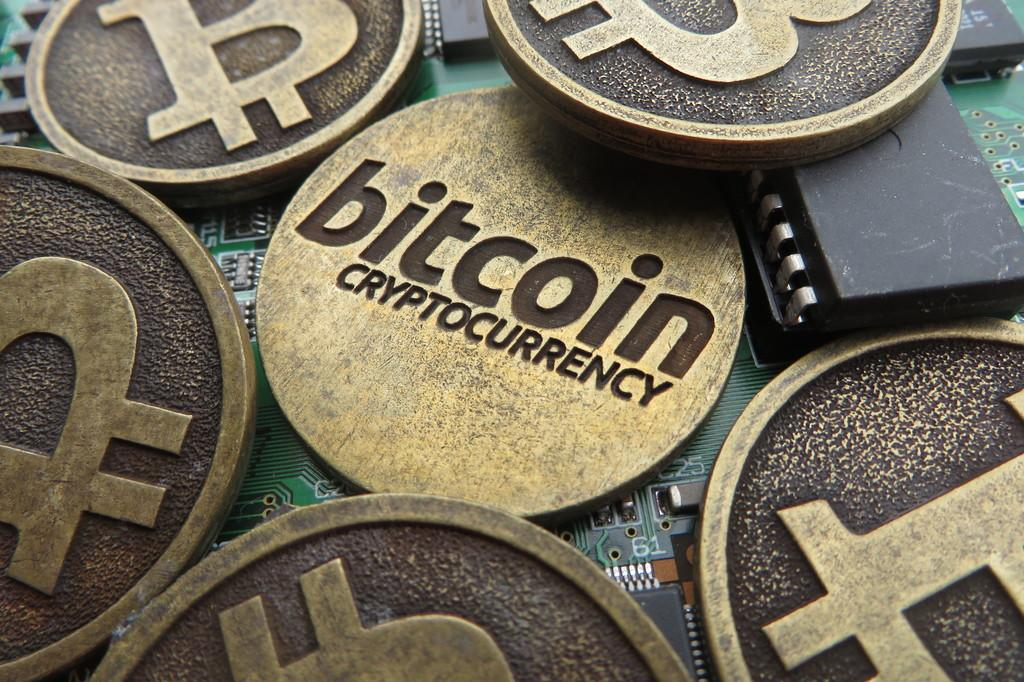<image>
Share a concise interpretation of the image provided. A few gold and black coins that show a B one one side and one coin is showing bitcoin cryptocurrency. 